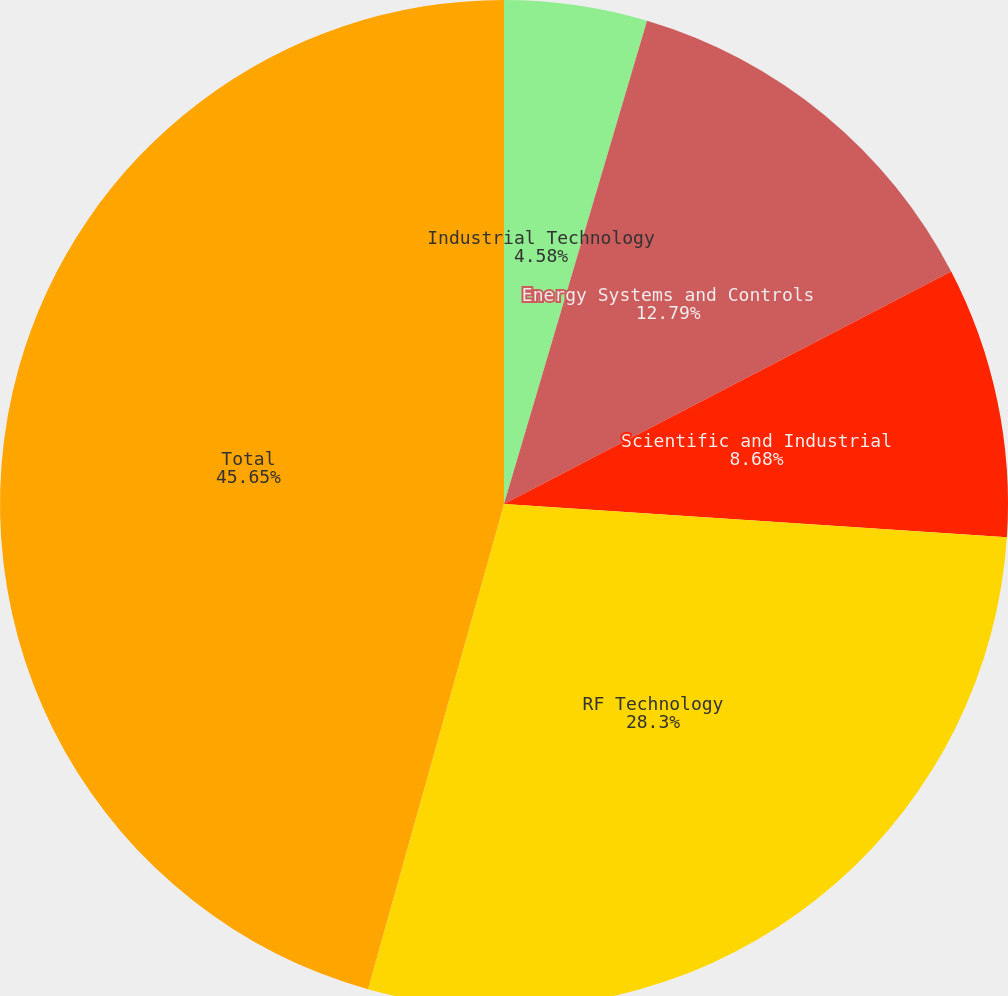Convert chart. <chart><loc_0><loc_0><loc_500><loc_500><pie_chart><fcel>Industrial Technology<fcel>Energy Systems and Controls<fcel>Scientific and Industrial<fcel>RF Technology<fcel>Total<nl><fcel>4.58%<fcel>12.79%<fcel>8.68%<fcel>28.3%<fcel>45.65%<nl></chart> 